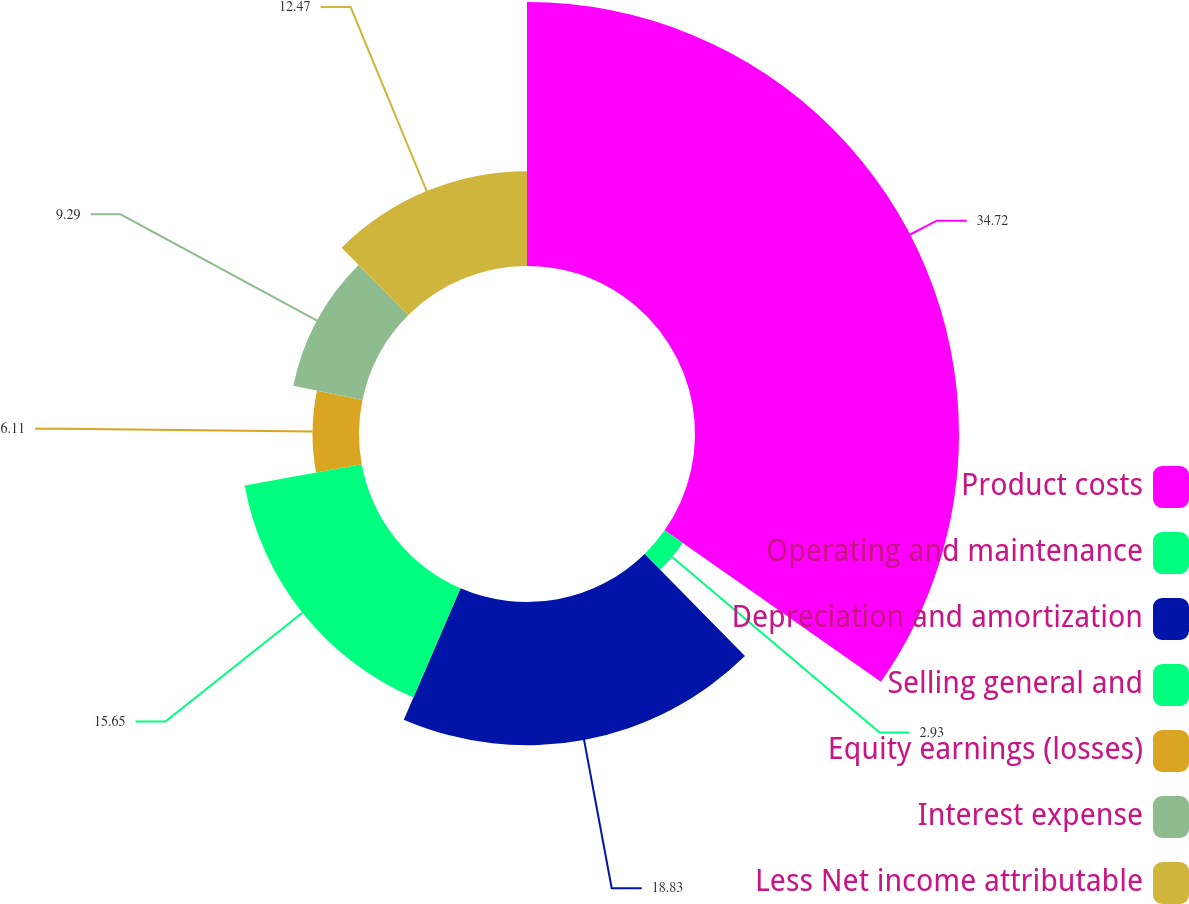Convert chart. <chart><loc_0><loc_0><loc_500><loc_500><pie_chart><fcel>Product costs<fcel>Operating and maintenance<fcel>Depreciation and amortization<fcel>Selling general and<fcel>Equity earnings (losses)<fcel>Interest expense<fcel>Less Net income attributable<nl><fcel>34.72%<fcel>2.93%<fcel>18.83%<fcel>15.65%<fcel>6.11%<fcel>9.29%<fcel>12.47%<nl></chart> 